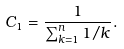<formula> <loc_0><loc_0><loc_500><loc_500>C _ { 1 } = \frac { 1 } { \sum _ { k = 1 } ^ { n } 1 / k } .</formula> 